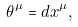Convert formula to latex. <formula><loc_0><loc_0><loc_500><loc_500>\theta ^ { \mu } = d x ^ { \mu } ,</formula> 